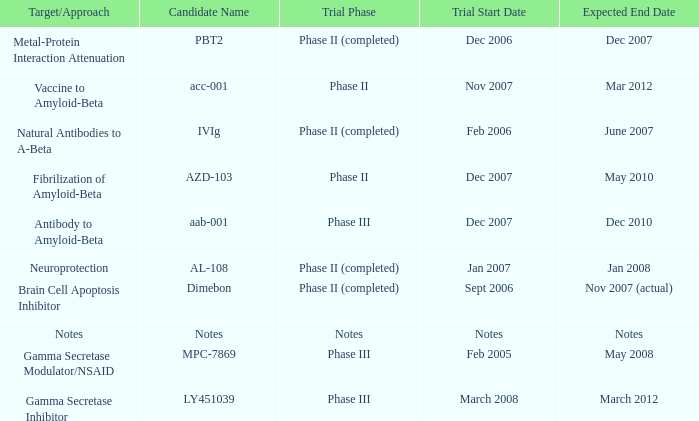What is Trial Start Date, when Candidate Name is PBT2? Dec 2006. Parse the full table. {'header': ['Target/Approach', 'Candidate Name', 'Trial Phase', 'Trial Start Date', 'Expected End Date'], 'rows': [['Metal-Protein Interaction Attenuation', 'PBT2', 'Phase II (completed)', 'Dec 2006', 'Dec 2007'], ['Vaccine to Amyloid-Beta', 'acc-001', 'Phase II', 'Nov 2007', 'Mar 2012'], ['Natural Antibodies to A-Beta', 'IVIg', 'Phase II (completed)', 'Feb 2006', 'June 2007'], ['Fibrilization of Amyloid-Beta', 'AZD-103', 'Phase II', 'Dec 2007', 'May 2010'], ['Antibody to Amyloid-Beta', 'aab-001', 'Phase III', 'Dec 2007', 'Dec 2010'], ['Neuroprotection', 'AL-108', 'Phase II (completed)', 'Jan 2007', 'Jan 2008'], ['Brain Cell Apoptosis Inhibitor', 'Dimebon', 'Phase II (completed)', 'Sept 2006', 'Nov 2007 (actual)'], ['Notes', 'Notes', 'Notes', 'Notes', 'Notes'], ['Gamma Secretase Modulator/NSAID', 'MPC-7869', 'Phase III', 'Feb 2005', 'May 2008'], ['Gamma Secretase Inhibitor', 'LY451039', 'Phase III', 'March 2008', 'March 2012']]} 